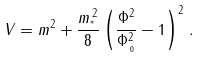Convert formula to latex. <formula><loc_0><loc_0><loc_500><loc_500>V = m ^ { 2 } + { \frac { m _ { ^ { * } } ^ { \, 2 } } { 8 } } \left ( { \frac { \Phi ^ { 2 } } { \Phi _ { \, _ { 0 } } ^ { 2 } } } - 1 \right ) ^ { 2 } \, .</formula> 